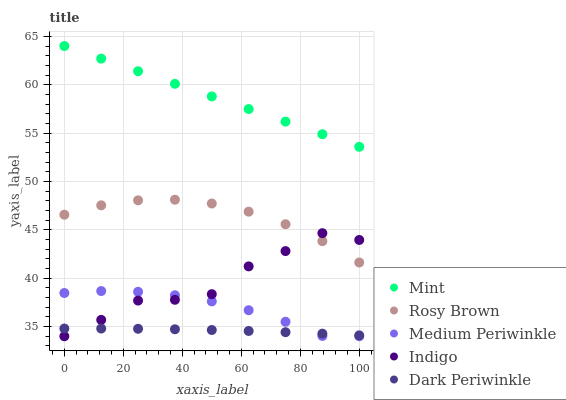Does Dark Periwinkle have the minimum area under the curve?
Answer yes or no. Yes. Does Mint have the maximum area under the curve?
Answer yes or no. Yes. Does Rosy Brown have the minimum area under the curve?
Answer yes or no. No. Does Rosy Brown have the maximum area under the curve?
Answer yes or no. No. Is Mint the smoothest?
Answer yes or no. Yes. Is Indigo the roughest?
Answer yes or no. Yes. Is Rosy Brown the smoothest?
Answer yes or no. No. Is Rosy Brown the roughest?
Answer yes or no. No. Does Medium Periwinkle have the lowest value?
Answer yes or no. Yes. Does Rosy Brown have the lowest value?
Answer yes or no. No. Does Mint have the highest value?
Answer yes or no. Yes. Does Rosy Brown have the highest value?
Answer yes or no. No. Is Indigo less than Mint?
Answer yes or no. Yes. Is Rosy Brown greater than Medium Periwinkle?
Answer yes or no. Yes. Does Dark Periwinkle intersect Medium Periwinkle?
Answer yes or no. Yes. Is Dark Periwinkle less than Medium Periwinkle?
Answer yes or no. No. Is Dark Periwinkle greater than Medium Periwinkle?
Answer yes or no. No. Does Indigo intersect Mint?
Answer yes or no. No. 